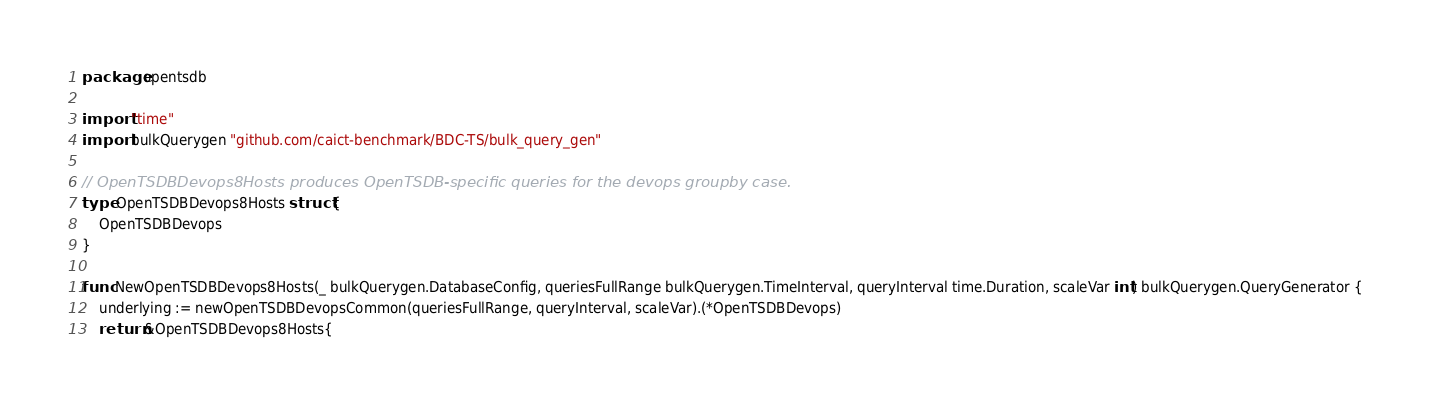Convert code to text. <code><loc_0><loc_0><loc_500><loc_500><_Go_>package opentsdb

import "time"
import bulkQuerygen "github.com/caict-benchmark/BDC-TS/bulk_query_gen"

// OpenTSDBDevops8Hosts produces OpenTSDB-specific queries for the devops groupby case.
type OpenTSDBDevops8Hosts struct {
	OpenTSDBDevops
}

func NewOpenTSDBDevops8Hosts(_ bulkQuerygen.DatabaseConfig, queriesFullRange bulkQuerygen.TimeInterval, queryInterval time.Duration, scaleVar int) bulkQuerygen.QueryGenerator {
	underlying := newOpenTSDBDevopsCommon(queriesFullRange, queryInterval, scaleVar).(*OpenTSDBDevops)
	return &OpenTSDBDevops8Hosts{</code> 